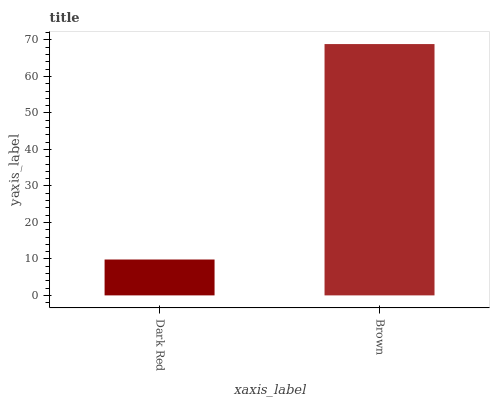Is Dark Red the minimum?
Answer yes or no. Yes. Is Brown the maximum?
Answer yes or no. Yes. Is Brown the minimum?
Answer yes or no. No. Is Brown greater than Dark Red?
Answer yes or no. Yes. Is Dark Red less than Brown?
Answer yes or no. Yes. Is Dark Red greater than Brown?
Answer yes or no. No. Is Brown less than Dark Red?
Answer yes or no. No. Is Brown the high median?
Answer yes or no. Yes. Is Dark Red the low median?
Answer yes or no. Yes. Is Dark Red the high median?
Answer yes or no. No. Is Brown the low median?
Answer yes or no. No. 